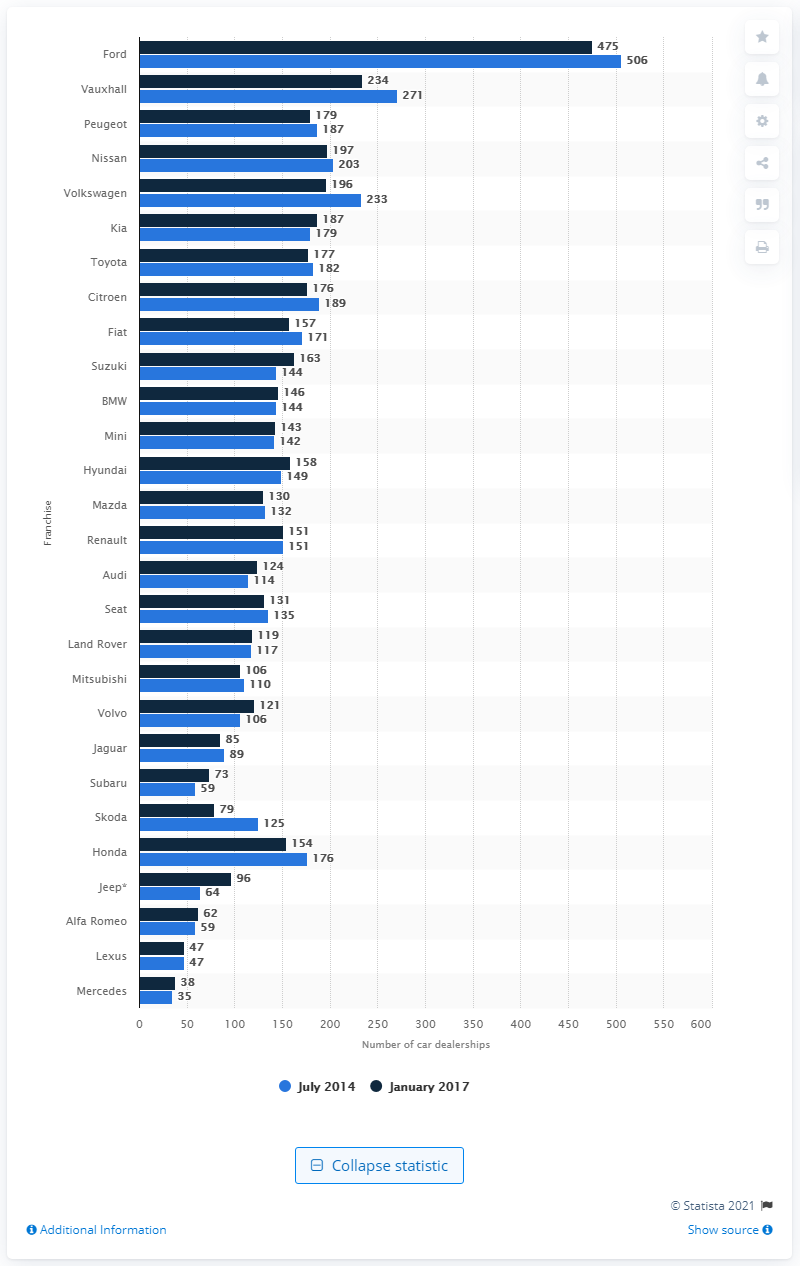Draw attention to some important aspects in this diagram. In the year 2017, Ford had a total of 475 dealerships operating in the United Kingdom. In January 2017, Ford had the largest dealership network in the United Kingdom. 